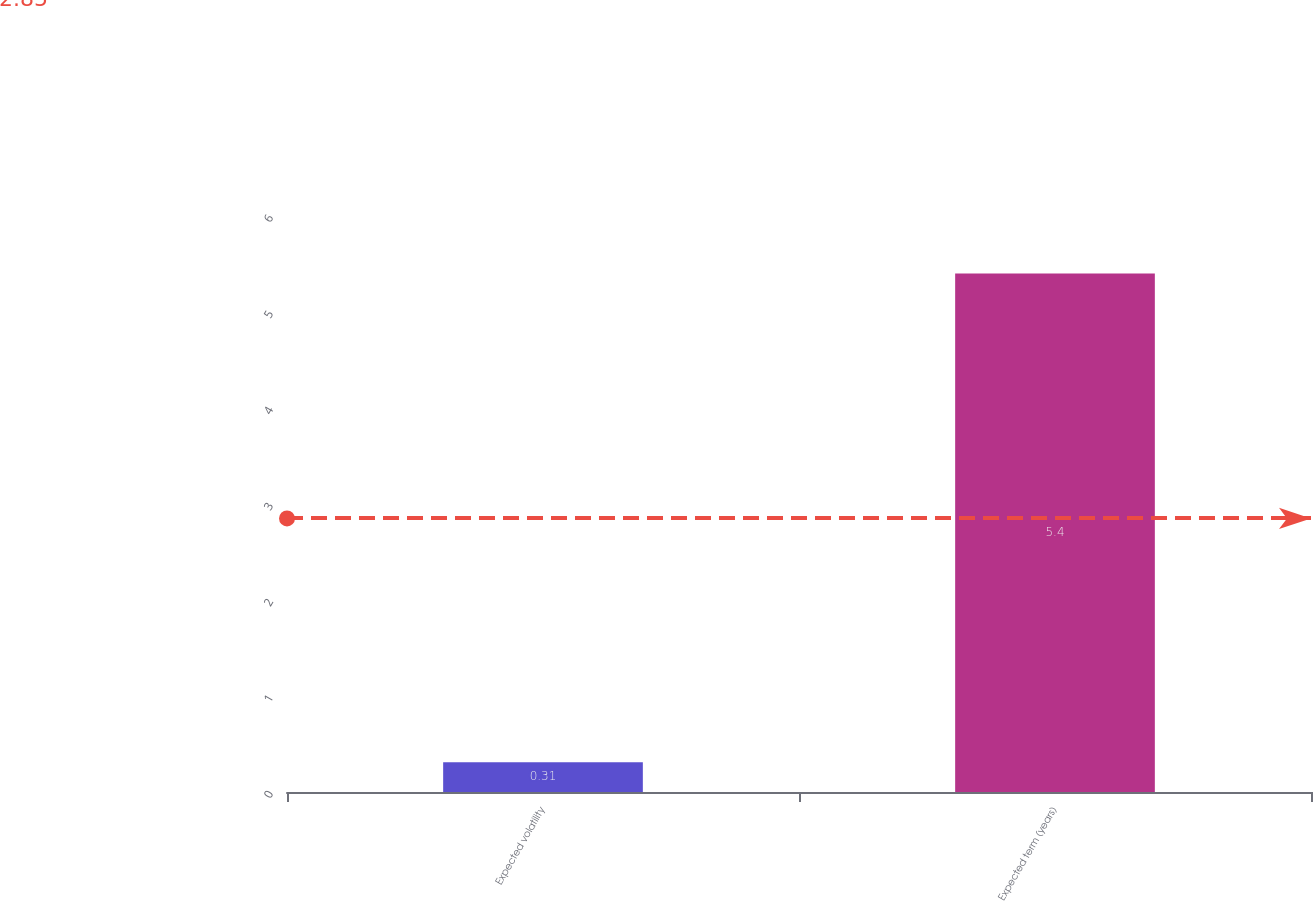<chart> <loc_0><loc_0><loc_500><loc_500><bar_chart><fcel>Expected volatility<fcel>Expected term (years)<nl><fcel>0.31<fcel>5.4<nl></chart> 